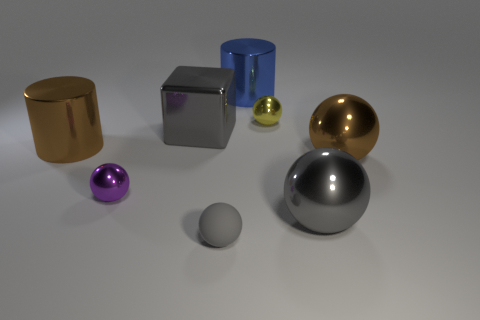There is a gray sphere that is the same material as the tiny yellow object; what size is it?
Ensure brevity in your answer.  Large. How many things are either tiny yellow shiny spheres behind the metallic cube or tiny metallic spheres that are on the right side of the large shiny block?
Keep it short and to the point. 1. What is the size of the metallic thing that is to the right of the large blue object and to the left of the big gray metallic sphere?
Make the answer very short. Small. Do the gray object to the right of the small rubber thing and the tiny gray object have the same shape?
Ensure brevity in your answer.  Yes. There is a gray thing that is on the right side of the big cylinder that is right of the big shiny object left of the small purple metal ball; how big is it?
Your answer should be very brief. Large. The shiny sphere that is the same color as the metallic block is what size?
Your response must be concise. Large. What number of things are tiny yellow cubes or brown shiny things?
Ensure brevity in your answer.  2. What is the shape of the metallic thing that is behind the big cube and in front of the large blue object?
Offer a very short reply. Sphere. There is a yellow shiny object; is it the same shape as the large gray object right of the small yellow shiny ball?
Ensure brevity in your answer.  Yes. There is a large gray sphere; are there any matte things behind it?
Offer a very short reply. No. 